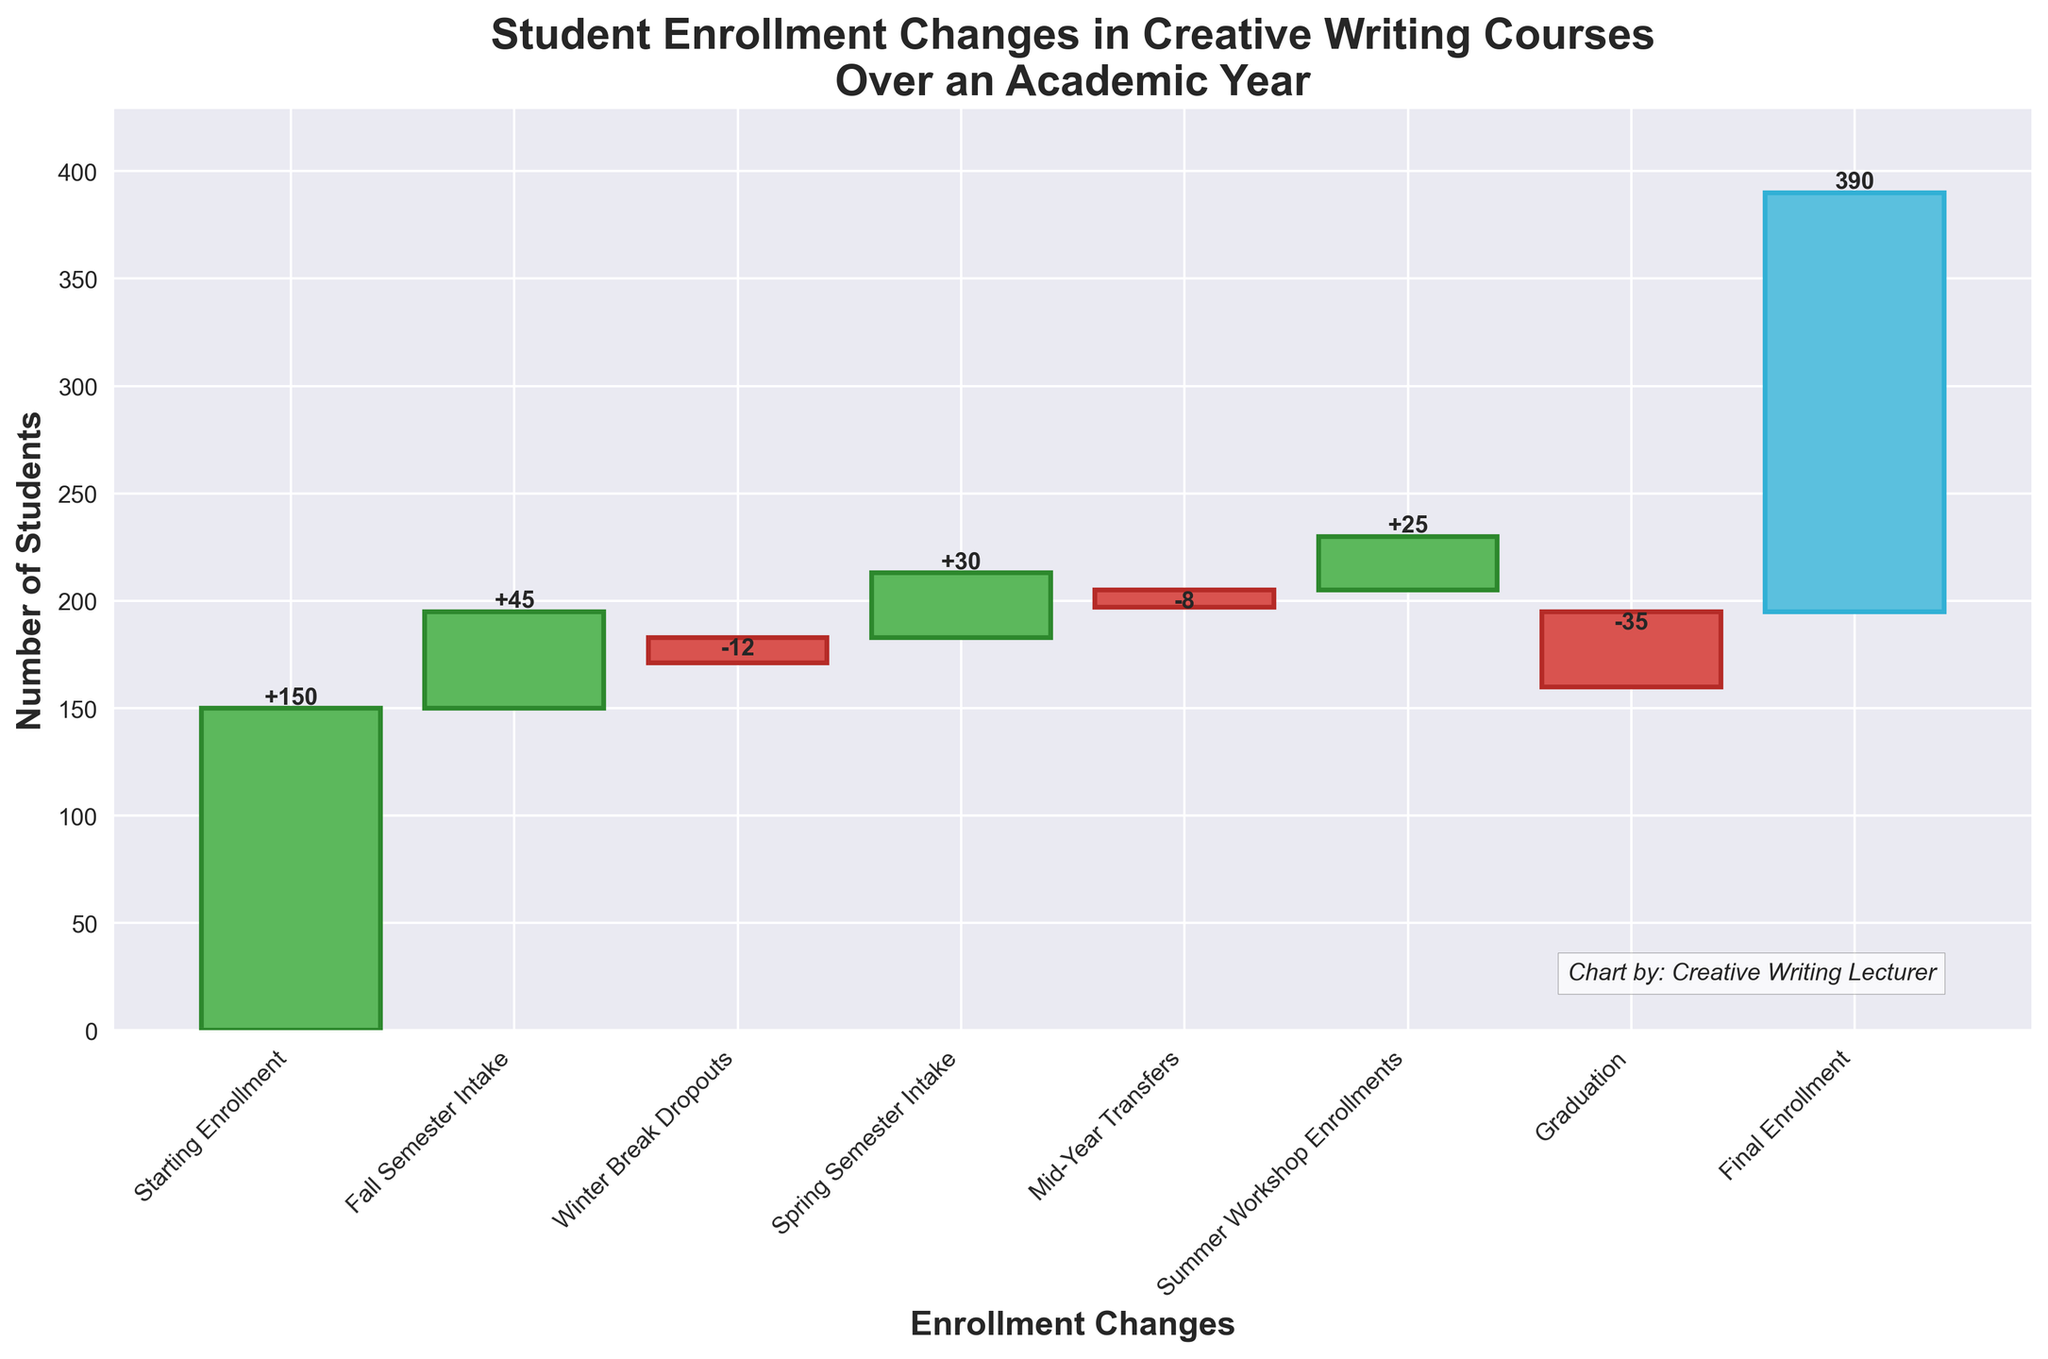How many categories are represented in the chart? The x-axis labels show each category in the chart, and when counting from "Starting Enrollment" to "Final Enrollment", you see a total of 8 categories.
Answer: 8 What is the fall semester intake's contribution to the enrollment change? The fall semester intake shows a label of +45, which indicates the number of students added during this period.
Answer: +45 What is the difference in student enrollment between the starting and final counts? The starting enrollment is 150 and the final enrollment is 195. Subtracting the starting count from the final count gives 195 - 150 = 45.
Answer: 45 How much did the student enrollment drop during the winter break? The bar labeled "Winter Break Dropouts" shows a change of -12, indicating the number of students who dropped out during this period.
Answer: -12 Which category had the greatest positive change? By comparing the positive changes listed, the "Fall Semester Intake" had the highest increase of +45 students.
Answer: Fall Semester Intake Which category had the greatest negative change? By comparing the negative changes shown, "Graduation" caused the greatest drop in enrollment, with -35 students.
Answer: Graduation What is the cumulative enrollment after the spring semester intake? Starting with 150 students, adding 45 (Fall Semester Intake) results in 195, subtracting 12 (Winter Break Dropouts) results in 183, and adding 30 (Spring Semester Intake) results in a cumulative total of 213 students.
Answer: 213 Is the final enrollment higher or lower than the starting enrollment? Comparing the starting enrollment of 150 students with the final enrollment of 195 students shows that the final enrollment is higher.
Answer: Higher What is the net change in student enrollment over the academic year? Starting enrollment is 150, and the final enrollment is 195. The net change is 195 - 150, which equals 45.
Answer: 45 Which enrollment change category occurs just before the "Graduation" change? Observing the sequential order in the chart, the "Summer Workshop Enrollments" category comes immediately before the "Graduation" change.
Answer: Summer Workshop Enrollments 